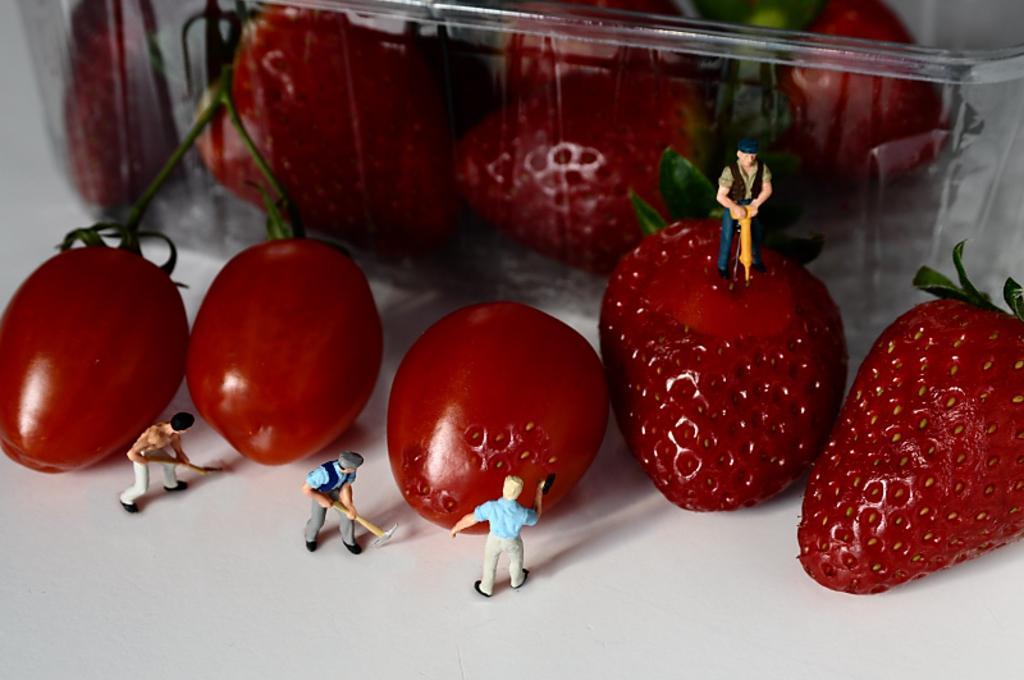Please provide a concise description of this image. In this image we can see the fruits and toys. At the top we can see fruits in a plastic box. 